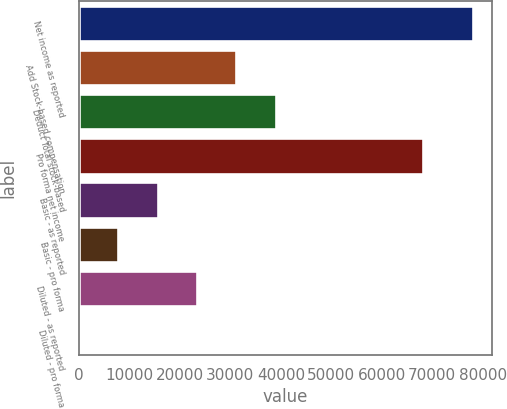<chart> <loc_0><loc_0><loc_500><loc_500><bar_chart><fcel>Net income as reported<fcel>Add Stock-based compensation<fcel>Deduct Total stock-based<fcel>Pro forma net income<fcel>Basic - as reported<fcel>Basic - pro forma<fcel>Diluted - as reported<fcel>Diluted - pro forma<nl><fcel>77992<fcel>31197.2<fcel>38996.3<fcel>68123<fcel>15598.9<fcel>7799.73<fcel>23398<fcel>0.59<nl></chart> 